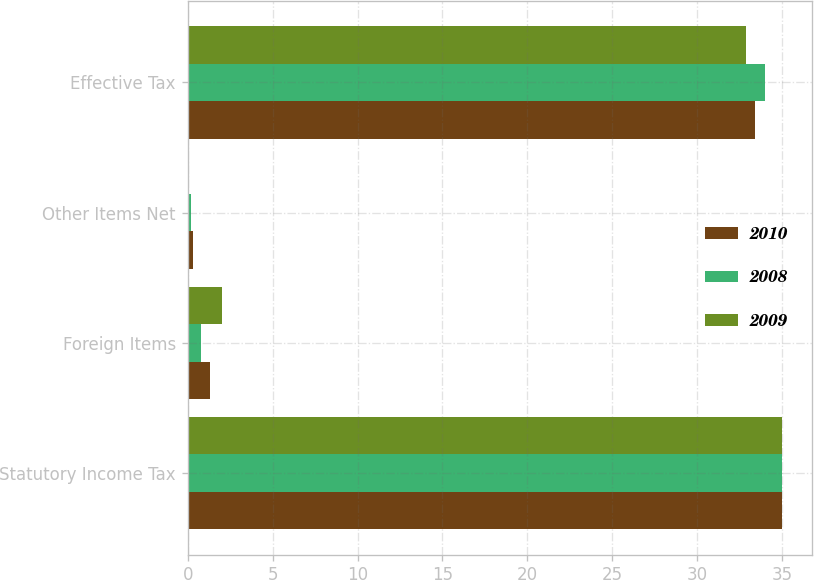<chart> <loc_0><loc_0><loc_500><loc_500><stacked_bar_chart><ecel><fcel>Statutory Income Tax<fcel>Foreign Items<fcel>Other Items Net<fcel>Effective Tax<nl><fcel>2010<fcel>35<fcel>1.3<fcel>0.3<fcel>33.4<nl><fcel>2008<fcel>35<fcel>0.8<fcel>0.2<fcel>34<nl><fcel>2009<fcel>35<fcel>2<fcel>0.1<fcel>32.9<nl></chart> 